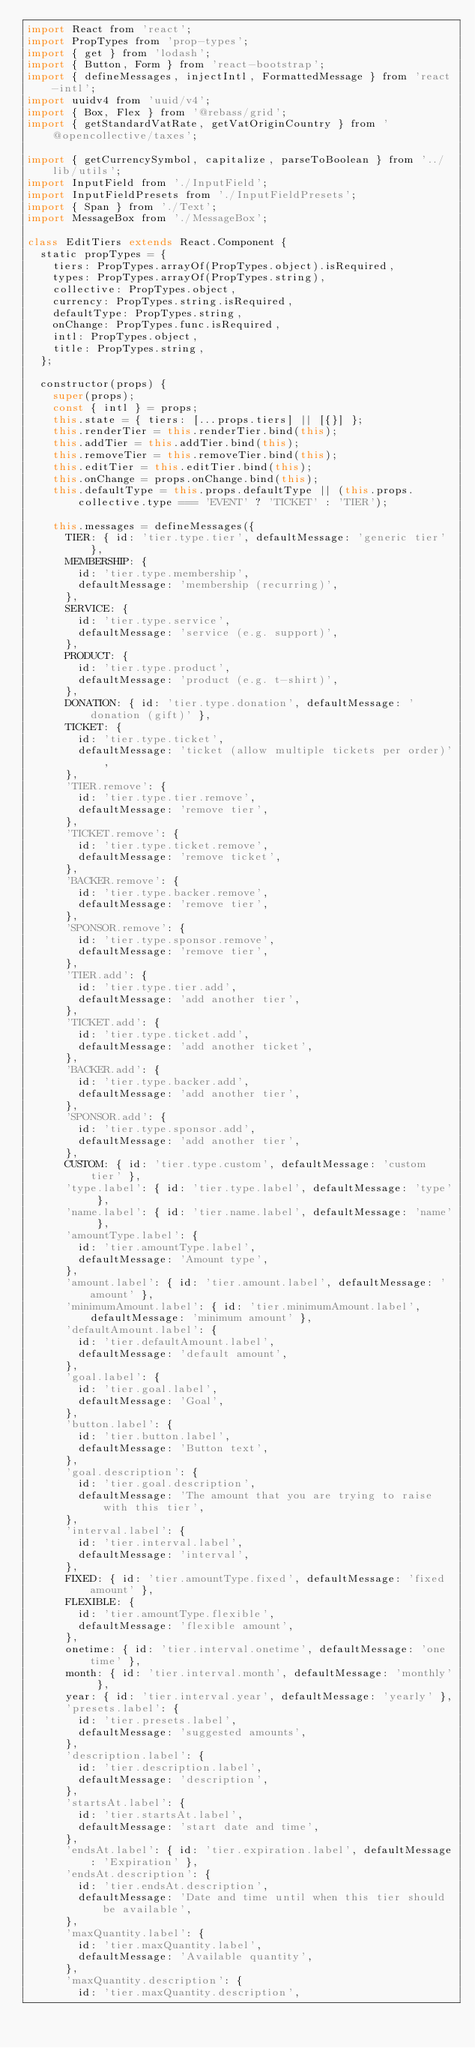<code> <loc_0><loc_0><loc_500><loc_500><_JavaScript_>import React from 'react';
import PropTypes from 'prop-types';
import { get } from 'lodash';
import { Button, Form } from 'react-bootstrap';
import { defineMessages, injectIntl, FormattedMessage } from 'react-intl';
import uuidv4 from 'uuid/v4';
import { Box, Flex } from '@rebass/grid';
import { getStandardVatRate, getVatOriginCountry } from '@opencollective/taxes';

import { getCurrencySymbol, capitalize, parseToBoolean } from '../lib/utils';
import InputField from './InputField';
import InputFieldPresets from './InputFieldPresets';
import { Span } from './Text';
import MessageBox from './MessageBox';

class EditTiers extends React.Component {
  static propTypes = {
    tiers: PropTypes.arrayOf(PropTypes.object).isRequired,
    types: PropTypes.arrayOf(PropTypes.string),
    collective: PropTypes.object,
    currency: PropTypes.string.isRequired,
    defaultType: PropTypes.string,
    onChange: PropTypes.func.isRequired,
    intl: PropTypes.object,
    title: PropTypes.string,
  };

  constructor(props) {
    super(props);
    const { intl } = props;
    this.state = { tiers: [...props.tiers] || [{}] };
    this.renderTier = this.renderTier.bind(this);
    this.addTier = this.addTier.bind(this);
    this.removeTier = this.removeTier.bind(this);
    this.editTier = this.editTier.bind(this);
    this.onChange = props.onChange.bind(this);
    this.defaultType = this.props.defaultType || (this.props.collective.type === 'EVENT' ? 'TICKET' : 'TIER');

    this.messages = defineMessages({
      TIER: { id: 'tier.type.tier', defaultMessage: 'generic tier' },
      MEMBERSHIP: {
        id: 'tier.type.membership',
        defaultMessage: 'membership (recurring)',
      },
      SERVICE: {
        id: 'tier.type.service',
        defaultMessage: 'service (e.g. support)',
      },
      PRODUCT: {
        id: 'tier.type.product',
        defaultMessage: 'product (e.g. t-shirt)',
      },
      DONATION: { id: 'tier.type.donation', defaultMessage: 'donation (gift)' },
      TICKET: {
        id: 'tier.type.ticket',
        defaultMessage: 'ticket (allow multiple tickets per order)',
      },
      'TIER.remove': {
        id: 'tier.type.tier.remove',
        defaultMessage: 'remove tier',
      },
      'TICKET.remove': {
        id: 'tier.type.ticket.remove',
        defaultMessage: 'remove ticket',
      },
      'BACKER.remove': {
        id: 'tier.type.backer.remove',
        defaultMessage: 'remove tier',
      },
      'SPONSOR.remove': {
        id: 'tier.type.sponsor.remove',
        defaultMessage: 'remove tier',
      },
      'TIER.add': {
        id: 'tier.type.tier.add',
        defaultMessage: 'add another tier',
      },
      'TICKET.add': {
        id: 'tier.type.ticket.add',
        defaultMessage: 'add another ticket',
      },
      'BACKER.add': {
        id: 'tier.type.backer.add',
        defaultMessage: 'add another tier',
      },
      'SPONSOR.add': {
        id: 'tier.type.sponsor.add',
        defaultMessage: 'add another tier',
      },
      CUSTOM: { id: 'tier.type.custom', defaultMessage: 'custom tier' },
      'type.label': { id: 'tier.type.label', defaultMessage: 'type' },
      'name.label': { id: 'tier.name.label', defaultMessage: 'name' },
      'amountType.label': {
        id: 'tier.amountType.label',
        defaultMessage: 'Amount type',
      },
      'amount.label': { id: 'tier.amount.label', defaultMessage: 'amount' },
      'minimumAmount.label': { id: 'tier.minimumAmount.label', defaultMessage: 'minimum amount' },
      'defaultAmount.label': {
        id: 'tier.defaultAmount.label',
        defaultMessage: 'default amount',
      },
      'goal.label': {
        id: 'tier.goal.label',
        defaultMessage: 'Goal',
      },
      'button.label': {
        id: 'tier.button.label',
        defaultMessage: 'Button text',
      },
      'goal.description': {
        id: 'tier.goal.description',
        defaultMessage: 'The amount that you are trying to raise with this tier',
      },
      'interval.label': {
        id: 'tier.interval.label',
        defaultMessage: 'interval',
      },
      FIXED: { id: 'tier.amountType.fixed', defaultMessage: 'fixed amount' },
      FLEXIBLE: {
        id: 'tier.amountType.flexible',
        defaultMessage: 'flexible amount',
      },
      onetime: { id: 'tier.interval.onetime', defaultMessage: 'one time' },
      month: { id: 'tier.interval.month', defaultMessage: 'monthly' },
      year: { id: 'tier.interval.year', defaultMessage: 'yearly' },
      'presets.label': {
        id: 'tier.presets.label',
        defaultMessage: 'suggested amounts',
      },
      'description.label': {
        id: 'tier.description.label',
        defaultMessage: 'description',
      },
      'startsAt.label': {
        id: 'tier.startsAt.label',
        defaultMessage: 'start date and time',
      },
      'endsAt.label': { id: 'tier.expiration.label', defaultMessage: 'Expiration' },
      'endsAt.description': {
        id: 'tier.endsAt.description',
        defaultMessage: 'Date and time until when this tier should be available',
      },
      'maxQuantity.label': {
        id: 'tier.maxQuantity.label',
        defaultMessage: 'Available quantity',
      },
      'maxQuantity.description': {
        id: 'tier.maxQuantity.description',</code> 